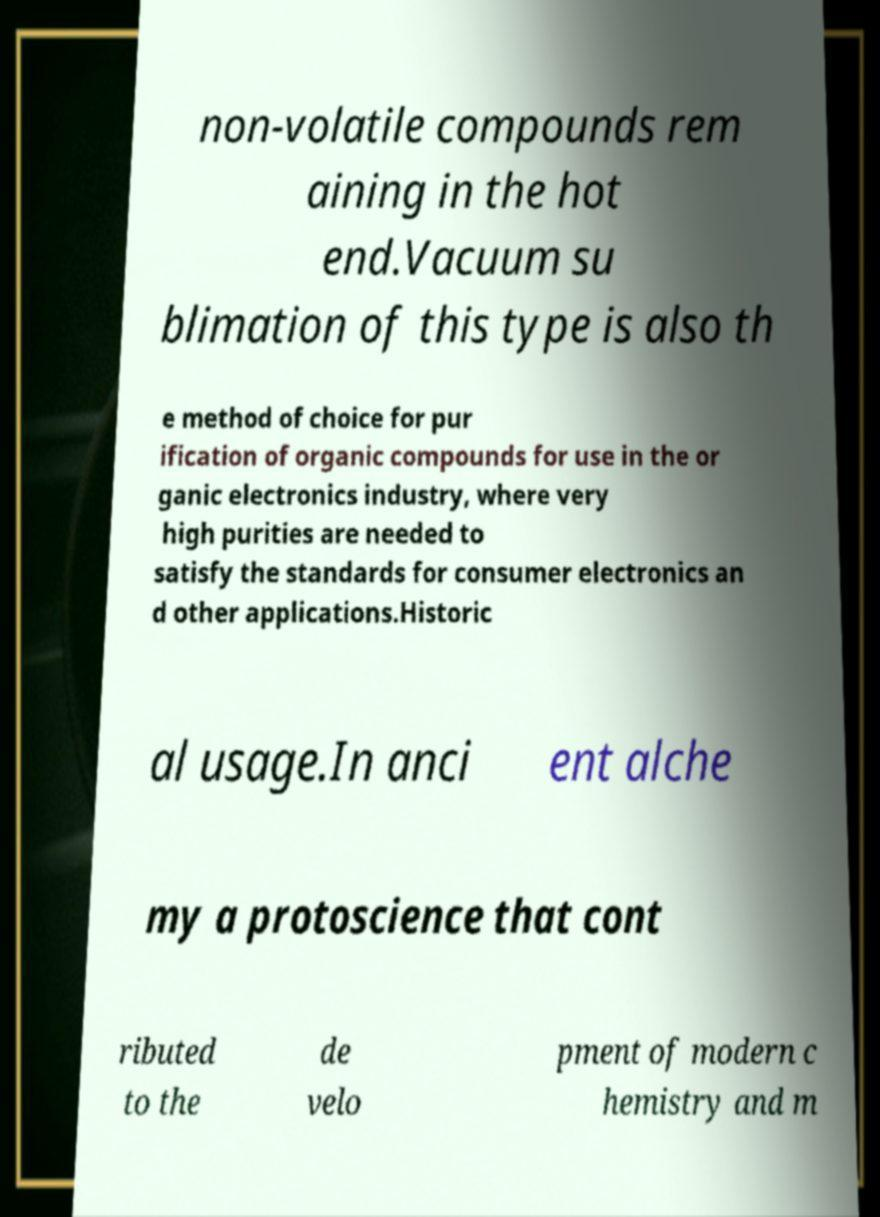Please read and relay the text visible in this image. What does it say? non-volatile compounds rem aining in the hot end.Vacuum su blimation of this type is also th e method of choice for pur ification of organic compounds for use in the or ganic electronics industry, where very high purities are needed to satisfy the standards for consumer electronics an d other applications.Historic al usage.In anci ent alche my a protoscience that cont ributed to the de velo pment of modern c hemistry and m 